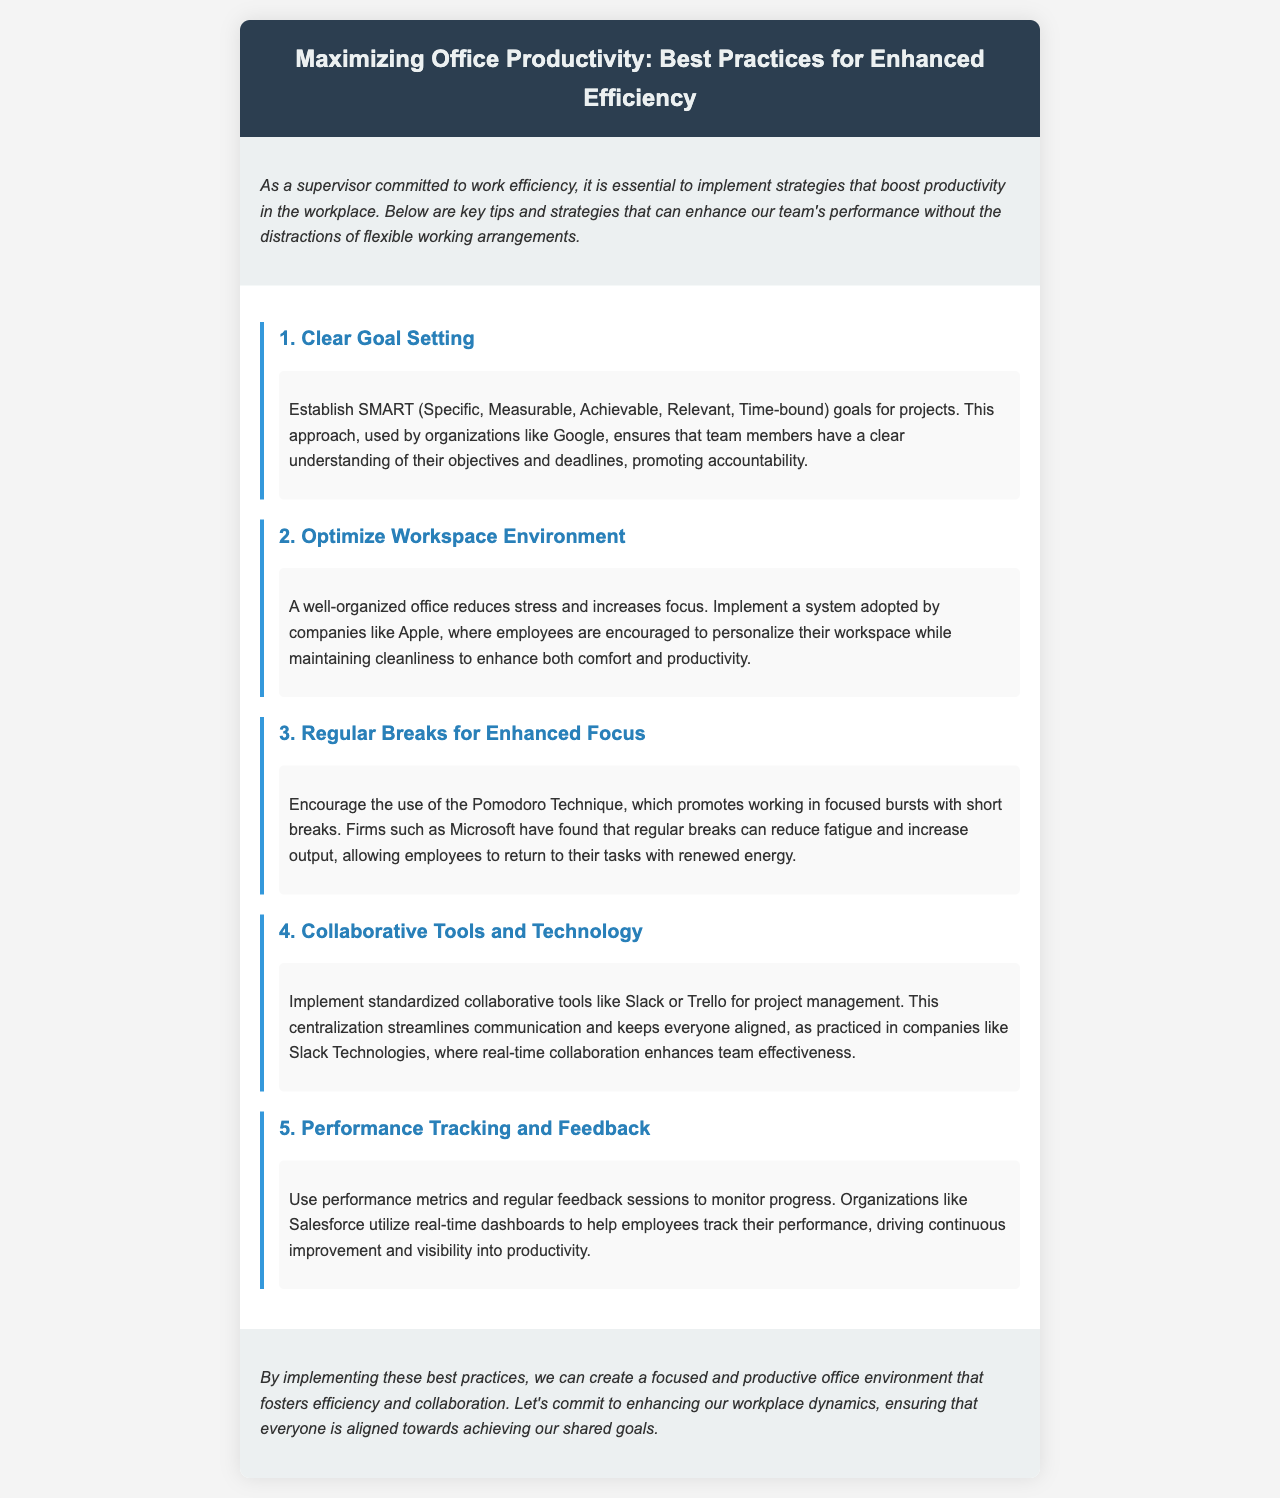What are the SMART goals? The SMART goals are defined as Specific, Measurable, Achievable, Relevant, and Time-bound.
Answer: Specific, Measurable, Achievable, Relevant, Time-bound Which company is mentioned in relation to optimizing workspace? Apple is noted for encouraging employees to personalize their workspace while maintaining cleanliness.
Answer: Apple What technique is recommended for taking breaks? The Pomodoro Technique is advised for enhancing focus with short breaks.
Answer: Pomodoro Technique Which company utilizes real-time dashboards for performance tracking? Salesforce is mentioned as using real-time dashboards for monitoring progress.
Answer: Salesforce What is the total number of productivity tips listed in the document? The document lists five distinct tips for enhancing office productivity.
Answer: Five What does the introduction emphasize about work arrangements? The introduction stresses that strategies should enhance productivity without the distractions of flexible working arrangements.
Answer: Without the distractions of flexible working arrangements What do the collaborative tools aim to streamline? The collaborative tools aim to streamline communication within the team.
Answer: Communication What type of work environment is promoted in the conclusion? The conclusion promotes a focused and productive office environment.
Answer: Focused and productive office environment 